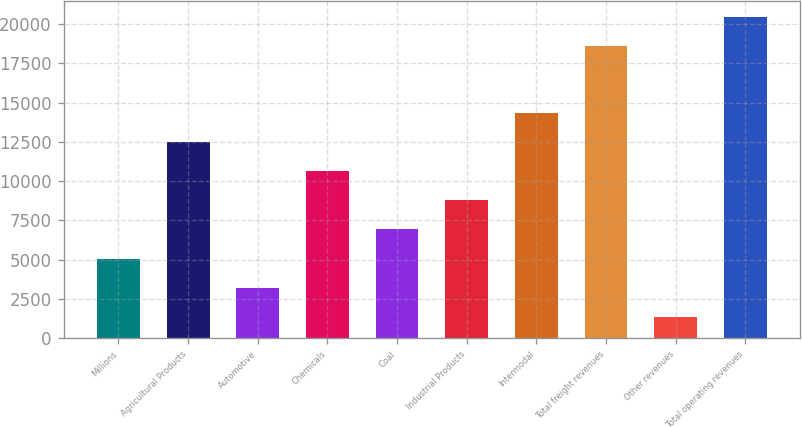<chart> <loc_0><loc_0><loc_500><loc_500><bar_chart><fcel>Millions<fcel>Agricultural Products<fcel>Automotive<fcel>Chemicals<fcel>Coal<fcel>Industrial Products<fcel>Intermodal<fcel>Total freight revenues<fcel>Other revenues<fcel>Total operating revenues<nl><fcel>5060.2<fcel>12500.6<fcel>3200.1<fcel>10640.5<fcel>6920.3<fcel>8780.4<fcel>14360.7<fcel>18601<fcel>1340<fcel>20461.1<nl></chart> 